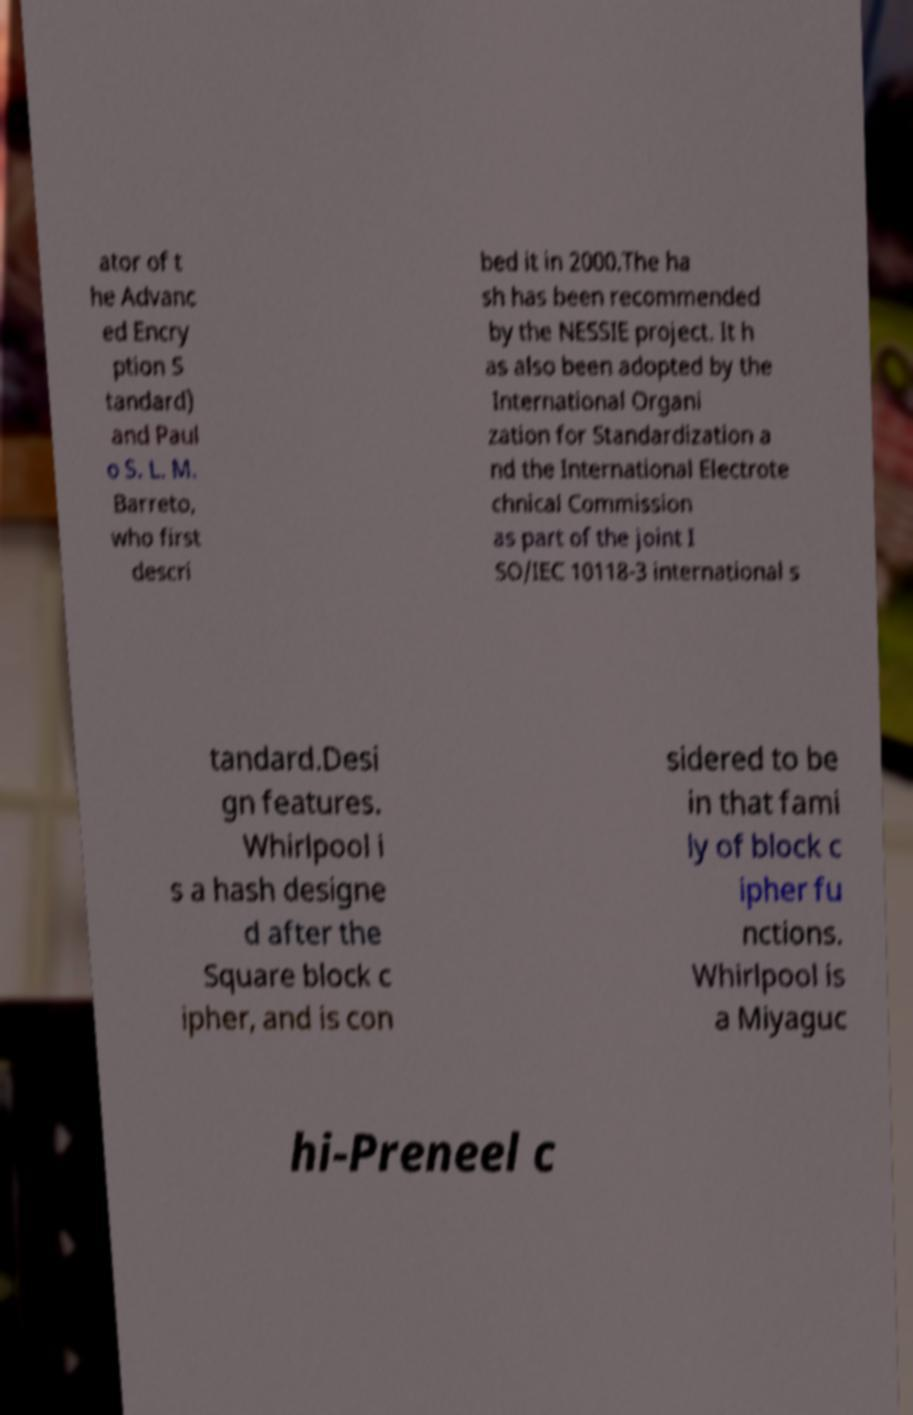There's text embedded in this image that I need extracted. Can you transcribe it verbatim? ator of t he Advanc ed Encry ption S tandard) and Paul o S. L. M. Barreto, who first descri bed it in 2000.The ha sh has been recommended by the NESSIE project. It h as also been adopted by the International Organi zation for Standardization a nd the International Electrote chnical Commission as part of the joint I SO/IEC 10118-3 international s tandard.Desi gn features. Whirlpool i s a hash designe d after the Square block c ipher, and is con sidered to be in that fami ly of block c ipher fu nctions. Whirlpool is a Miyaguc hi-Preneel c 